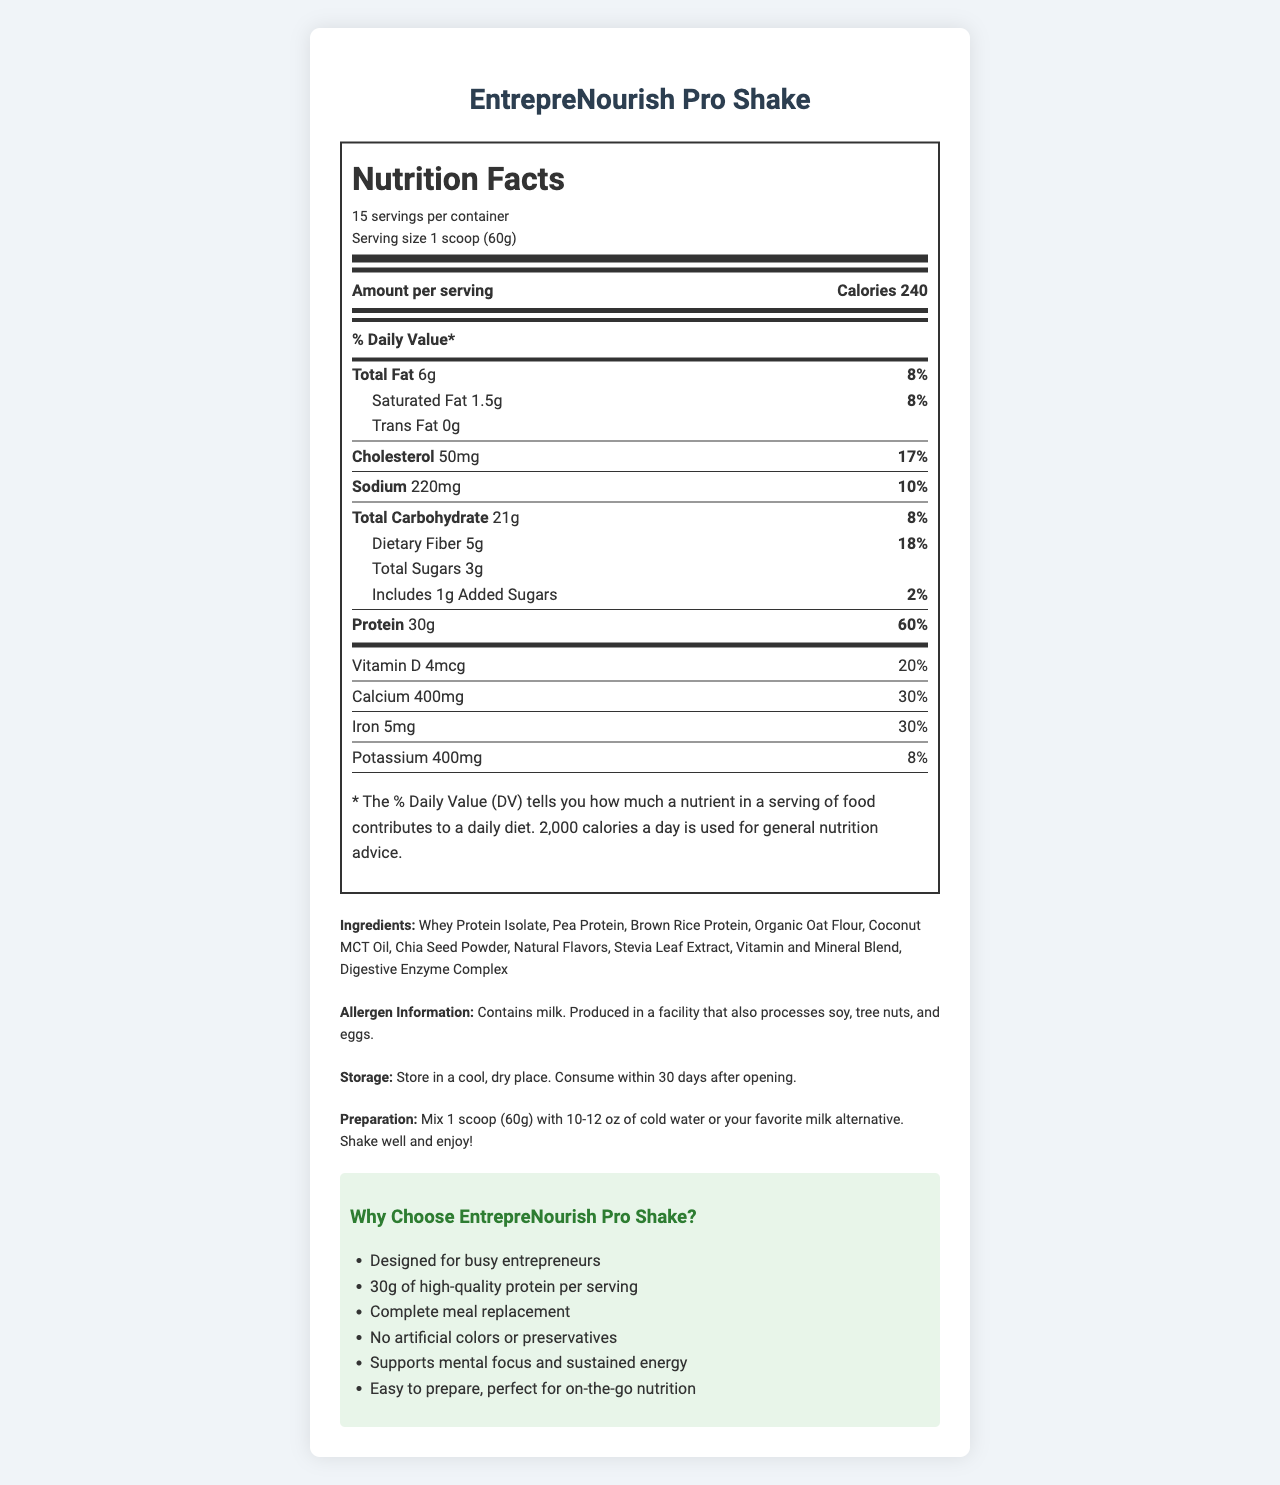what is the serving size of EntrepreNourish Pro Shake? The serving size is clearly mentioned in the nutrition facts section as "1 scoop (60g)".
Answer: 1 scoop (60g) how many servings are there per container? The document states that there are 15 servings per container.
Answer: 15 how much protein is in each serving? The protein content per serving is listed as 30g in the nutrition facts section.
Answer: 30g what is the percentage of daily value for calcium? The daily value for calcium is listed as 30% in the nutrition facts section.
Answer: 30% what are the main sources of protein in this shake? The ingredients list includes Whey Protein Isolate, Pea Protein, and Brown Rice Protein as the main sources of protein.
Answer: Whey Protein Isolate, Pea Protein, Brown Rice Protein how many calories are in one serving of the shake? A. 120 B. 180 C. 240 D. 300 The document lists the calorie content per serving as 240.
Answer: C which nutrient has the highest daily value percentage? A. Protein B. Vitamin C C. Calcium D. Dietary Fiber The protein content has the highest daily value percentage at 60%.
Answer: A does this shake contain any added sugars? The label states that it includes 1g of added sugars.
Answer: Yes is the shake suitable for someone with a soy allergy? The allergen information indicates that it is produced in a facility that also processes soy.
Answer: No what is the main objective of the document? The document presents a comprehensive nutritional profile, ingredients, preparation and storage instructions, and marketing claims for EntrepreNourish Pro Shake.
Answer: To provide detailed nutritional information about EntrepreNourish Pro Shake what is the exact amount of vitamin D per serving? The nutrition facts specify that there are 4mcg of vitamin D per serving.
Answer: 4mcg which vitamins are included at 50% of the daily value? Several vitamins listed at 50% of the daily value include Vitamin A, Vitamin C, Vitamin E, Vitamin K, among others.
Answer: Vitamin A, Vitamin C, Vitamin E, Vitamin K, Thiamin, Riboflavin, Niacin, Vitamin B6, Folate, Vitamin B12, Biotin, Pantothenic Acid, Iodine, Zinc, Selenium, Copper, Manganese, Chromium, Molybdenum what are the storage instructions for the shake? The storage instructions provided are to store in a cool, dry place and to consume within 30 days after opening.
Answer: Store in a cool, dry place. Consume within 30 days after opening. does this product use artificial colors? One of the marketing claims states that it has no artificial colors or preservatives.
Answer: No what are the total carbohydrates in each serving? The nutrition label lists the total carbohydrates as 21g per serving.
Answer: 21g how should the shake be prepared? The preparation instructions specify mixing 1 scoop with 10-12 oz of cold water or milk alternative and shaking well.
Answer: Mix 1 scoop (60g) with 10-12 oz of cold water or your favorite milk alternative. Shake well and enjoy! what flavorings are used in the shake? The ingredients list includes Natural Flavors and Stevia Leaf Extract as flavorings.
Answer: Natural Flavors, Stevia Leaf Extract what is the daily value percentage for dietary fiber? The document states that the daily value percentage for dietary fiber is 18%.
Answer: 18% is this product suitable for vegans? The document provides the ingredients but doesn't explicitly state if they are vegan or if the product is certified vegan.
Answer: Not enough information 